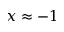<formula> <loc_0><loc_0><loc_500><loc_500>x \approx - 1</formula> 